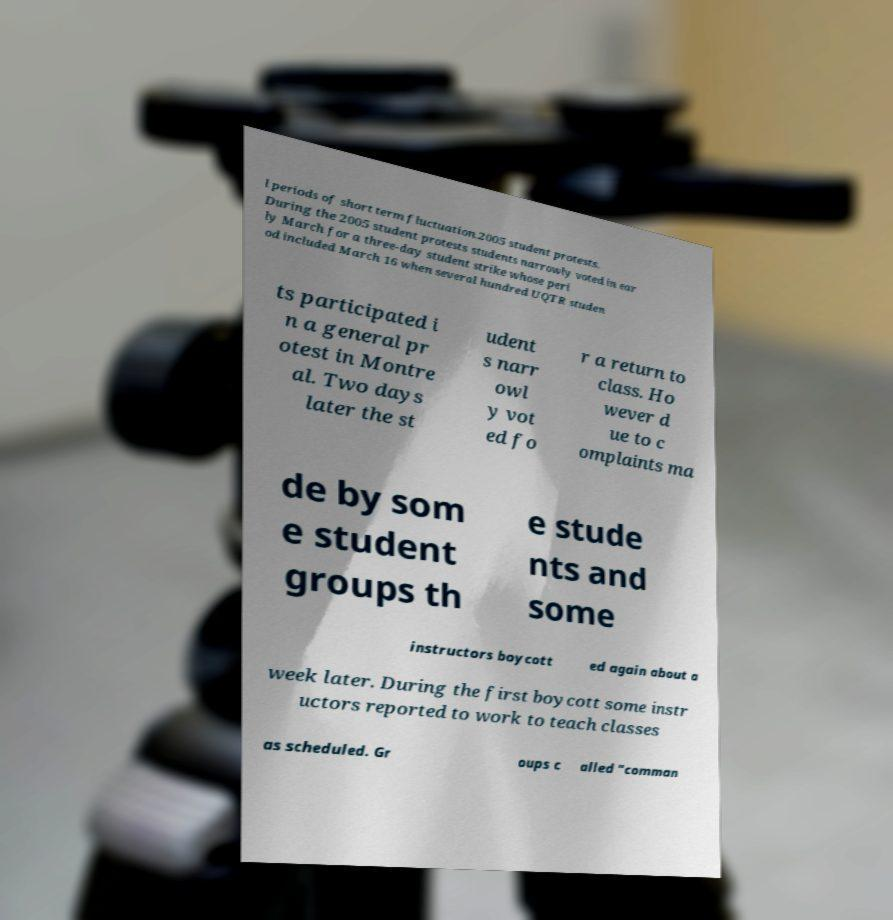For documentation purposes, I need the text within this image transcribed. Could you provide that? l periods of short term fluctuation.2005 student protests. During the 2005 student protests students narrowly voted in ear ly March for a three-day student strike whose peri od included March 16 when several hundred UQTR studen ts participated i n a general pr otest in Montre al. Two days later the st udent s narr owl y vot ed fo r a return to class. Ho wever d ue to c omplaints ma de by som e student groups th e stude nts and some instructors boycott ed again about a week later. During the first boycott some instr uctors reported to work to teach classes as scheduled. Gr oups c alled "comman 